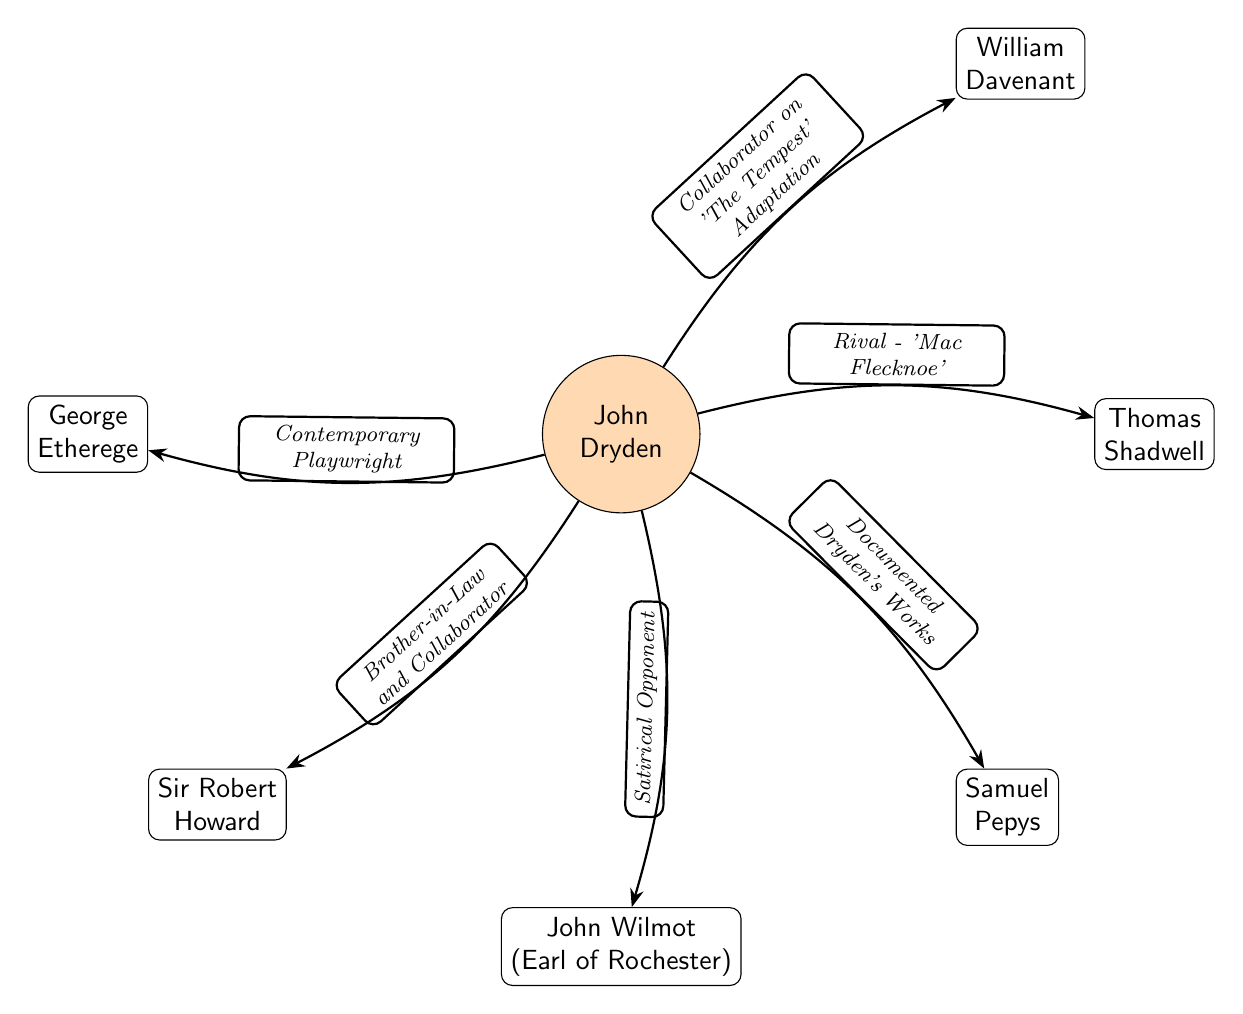What is the main node in the diagram? The main node represents the central figure, John Dryden, as indicated in the diagram.
Answer: John Dryden How many nodes are there in total? Counting all individual nodes connected to the main node, there are six nodes in total surrounding John Dryden.
Answer: 6 What is the relationship between John Dryden and Thomas Shadwell? The relationship described indicates that Thomas Shadwell is a rival to John Dryden as noted in the diagram.
Answer: Rival - 'Mac Flecknoe' Which figure is mentioned as a collaborator on 'The Tempest' adaptation? The diagram specifies that William Davenant collaborated with John Dryden on the adaptation of 'The Tempest'.
Answer: William Davenant What role does Samuel Pepys have in relation to John Dryden? The diagram states that Samuel Pepys documented John Dryden's works, indicating an observational or supporting role.
Answer: Documented Dryden's Works Who is noted as John Dryden's brother-in-law and collaborator? The relationship specified in the diagram points to Sir Robert Howard as both a brother-in-law and collaborator.
Answer: Sir Robert Howard How many different types of relationships are represented in the edges? There are five distinct relationships described in the connections between John Dryden and the other figures, including collaboration and rivalry.
Answer: 5 Who is described as a satirical opponent to John Dryden? The diagram notes John Wilmot, the Earl of Rochester, as a satirical opponent in relation to John Dryden.
Answer: John Wilmot What phrase describes George Etherege's relationship to John Dryden? The diagram indicates that George Etherege is a contemporary playwright in relation to John Dryden, showing their simultaneous activity.
Answer: Contemporary Playwright 